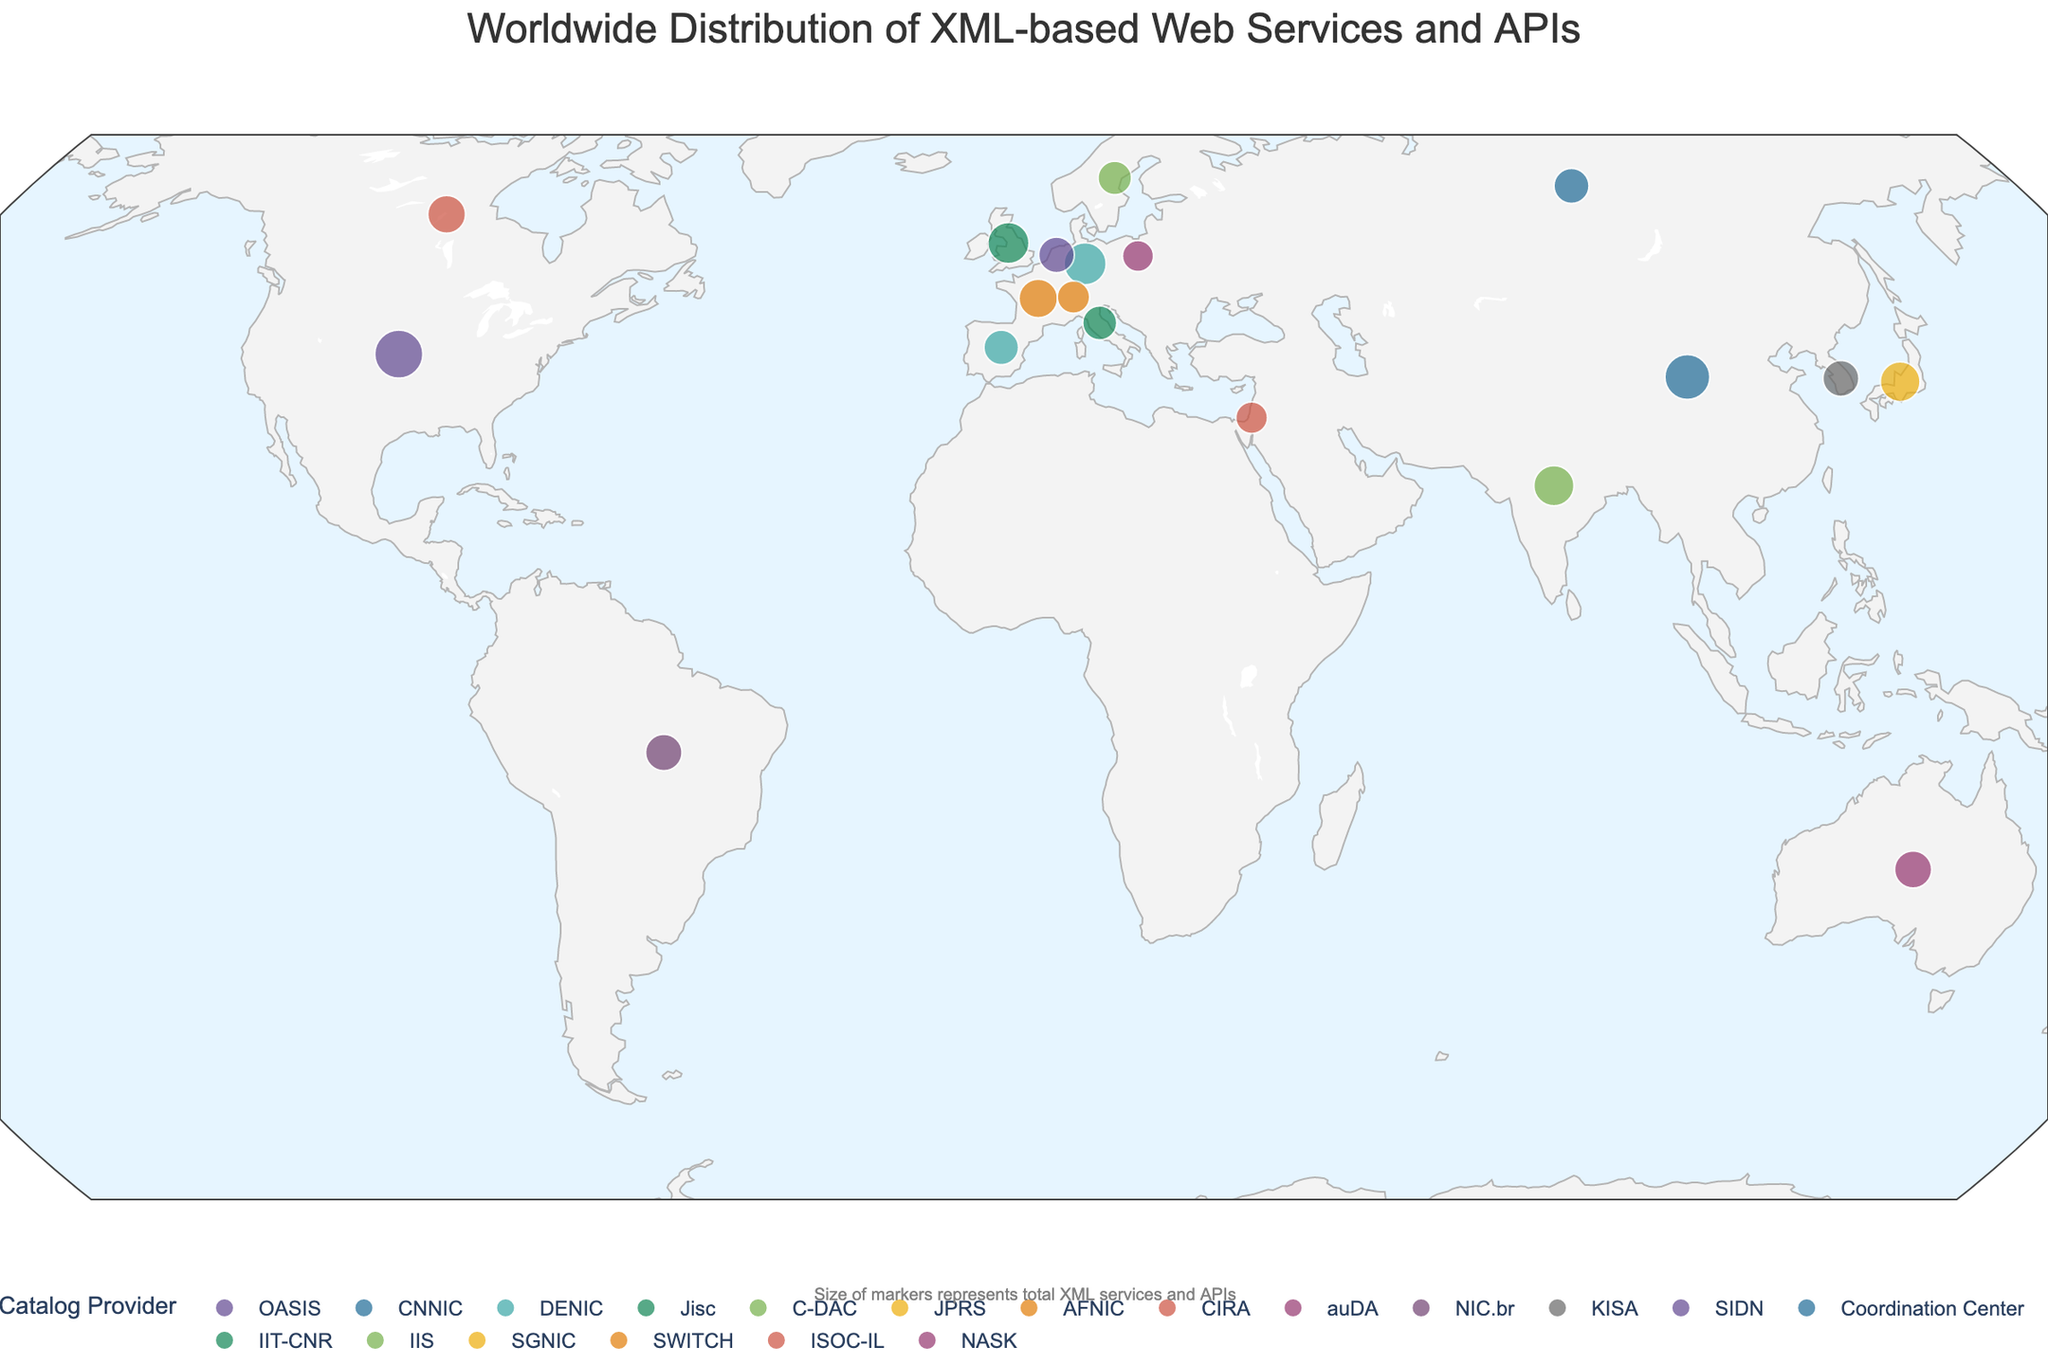What is the title of the plot? The title could be seen at the top of the plot. It is often used to provide an overview of what the plot is about. It's displayed prominently and often larger than other text on the plot.
Answer: Worldwide Distribution of XML-based Web Services and APIs Which country has the highest number of XML Web Services? To answer this, look for the country with the largest circle on the plot specifically accounting for the "XML_Web_Services" data indicated in the hover information.
Answer: United States For Germany, how many total XML-based services (both Web Services and APIs) are there? Add up the "XML_Web_Services" and "XML_APIs" values for Germany to get the total. These numbers are 750 and 560, respectively. 750 + 560 = 1310
Answer: 1310 Which country has the smallest representation of XML-based services on the plot? Look for the smallest circle on the plot, which indicates the minimal sum of "XML_Web_Services" and "XML_APIs". Also, confirm through the hover information that highlights the exact values.
Answer: Poland Who is the major XML Catalog provider for the United Kingdom? Hover over the circle representing the United Kingdom and check the information displayed. "Major_XML_Catalog_Provider" will be listed among the metadata shown.
Answer: Jisc How many more XML APIs does the United States have than Canada? Determine the number of "XML_APIs" for both countries and subtract the value for Canada from that of the United States. United States has 980 and Canada has 370. 980 - 370 = 610
Answer: 610 Compare the total XML services between China and India. Which country has more, and by how much? Calculate the total of "XML_Web_Services" and "XML_APIs" for each country (China: 980 + 720, India: 620 + 470), then find the difference. (1700 for China, 1090 for India, China has 610 more)
Answer: China by 610 What color represents the major XML catalog for the United States on the plot? Identify the color used for the United States by checking the legend, which maps colors to catalog providers, or by hovering over the circle.
Answer: The specific color depends on the plot's palette but it represents OASIS How is the size of the markers determined on the plot? The data indicates size is proportional to the square root of the sum of XML Web Services and APIs. This means larger values of total services result in bigger marker sizes.
Answer: By the square root of total XML services and APIs Which countries have exactly 240 and 220 XML Web Services respectively? To answer this, locate the circles with markers labeled 240 and 220 under "XML_Web_Services" by hovering over the countries.
Answer: Italy (240) and Poland (220) 